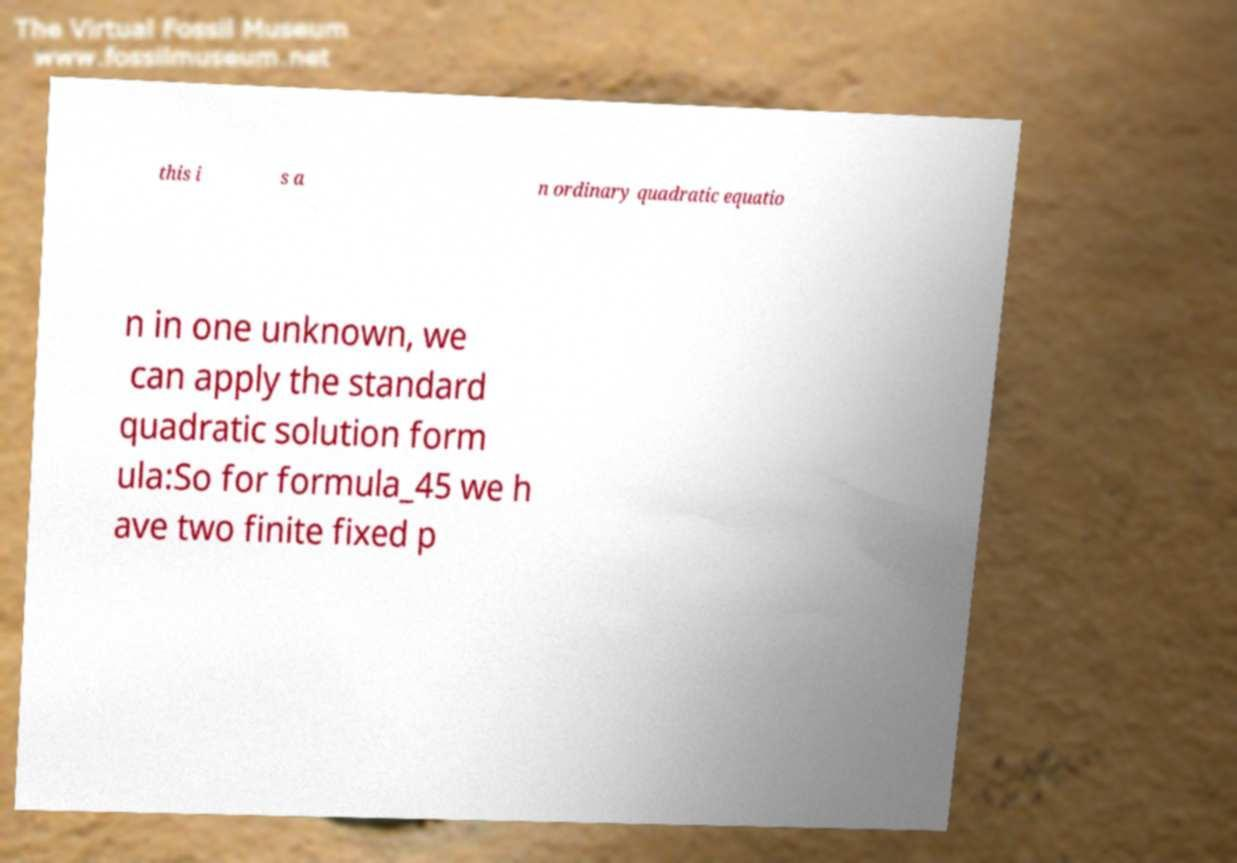What messages or text are displayed in this image? I need them in a readable, typed format. this i s a n ordinary quadratic equatio n in one unknown, we can apply the standard quadratic solution form ula:So for formula_45 we h ave two finite fixed p 